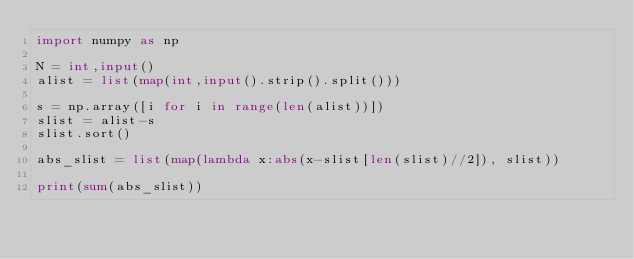Convert code to text. <code><loc_0><loc_0><loc_500><loc_500><_Python_>import numpy as np

N = int,input()
alist = list(map(int,input().strip().split()))

s = np.array([i for i in range(len(alist))])
slist = alist-s
slist.sort()

abs_slist = list(map(lambda x:abs(x-slist[len(slist)//2]), slist))

print(sum(abs_slist))
</code> 